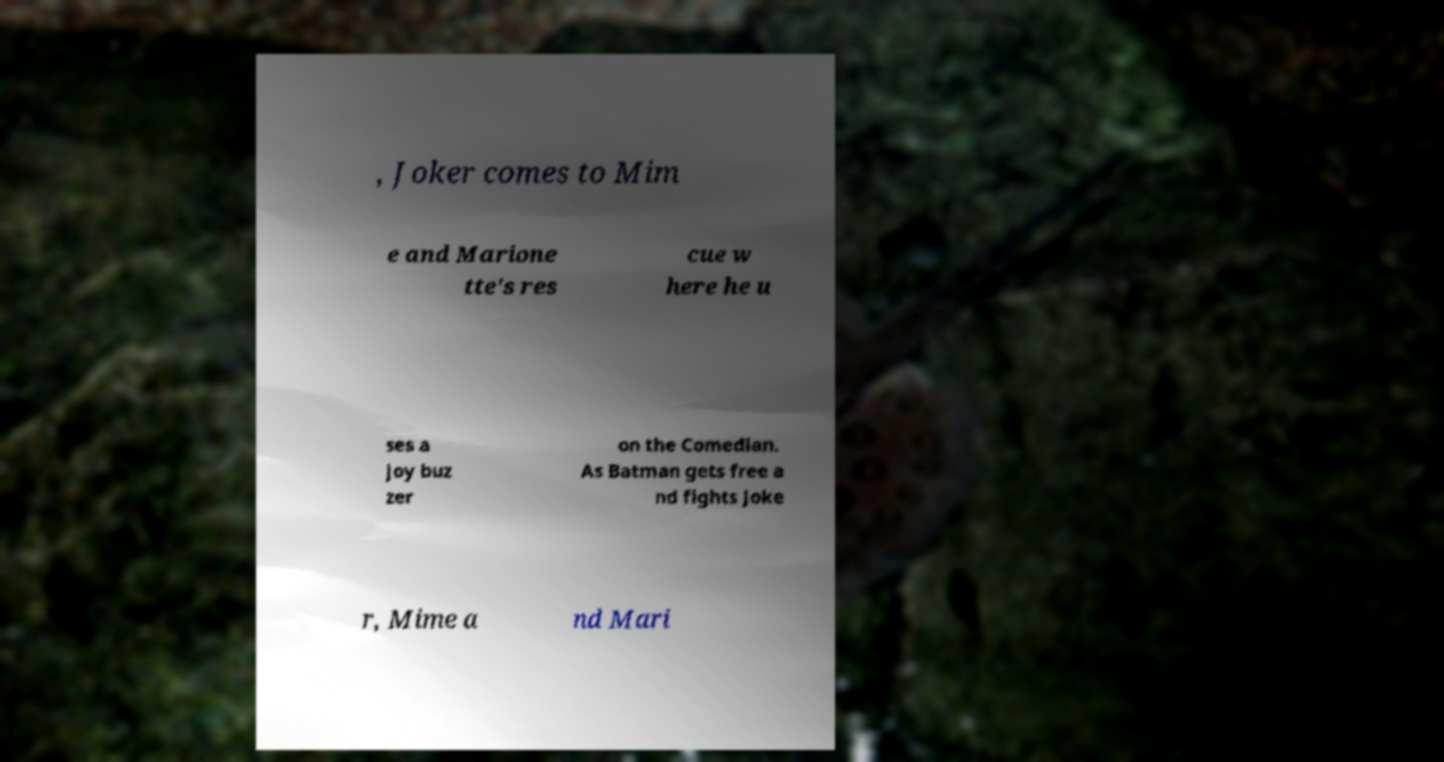Could you extract and type out the text from this image? , Joker comes to Mim e and Marione tte's res cue w here he u ses a joy buz zer on the Comedian. As Batman gets free a nd fights Joke r, Mime a nd Mari 